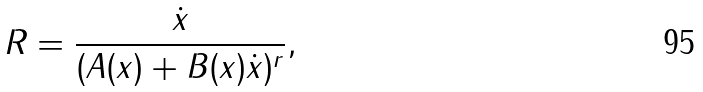Convert formula to latex. <formula><loc_0><loc_0><loc_500><loc_500>R = \frac { \dot { x } } { ( A ( x ) + B ( x ) \dot { x } ) ^ { r } } ,</formula> 